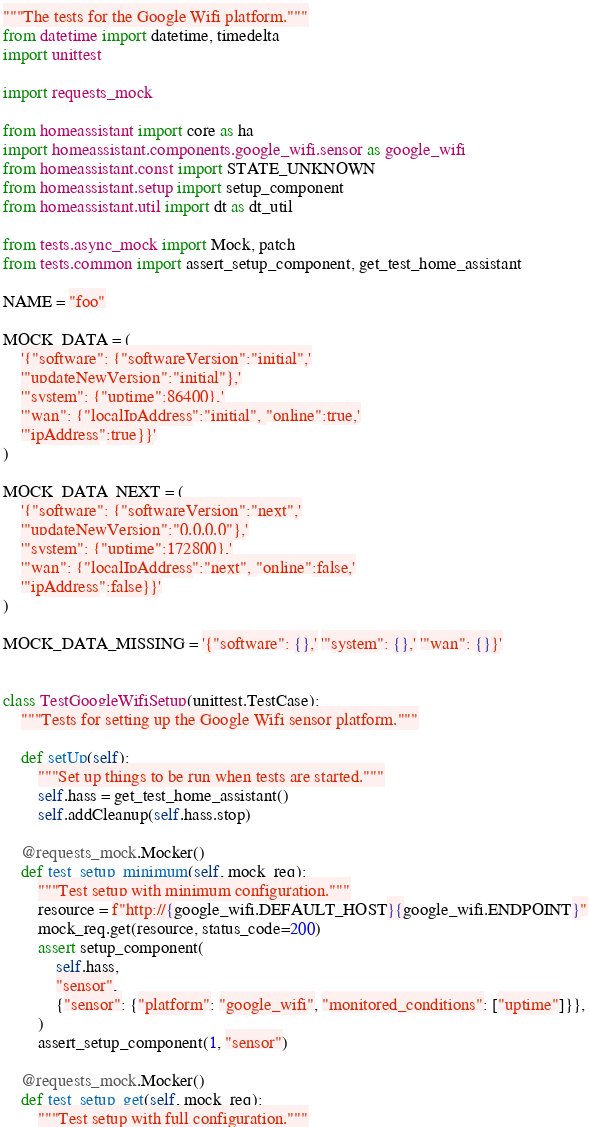Convert code to text. <code><loc_0><loc_0><loc_500><loc_500><_Python_>"""The tests for the Google Wifi platform."""
from datetime import datetime, timedelta
import unittest

import requests_mock

from homeassistant import core as ha
import homeassistant.components.google_wifi.sensor as google_wifi
from homeassistant.const import STATE_UNKNOWN
from homeassistant.setup import setup_component
from homeassistant.util import dt as dt_util

from tests.async_mock import Mock, patch
from tests.common import assert_setup_component, get_test_home_assistant

NAME = "foo"

MOCK_DATA = (
    '{"software": {"softwareVersion":"initial",'
    '"updateNewVersion":"initial"},'
    '"system": {"uptime":86400},'
    '"wan": {"localIpAddress":"initial", "online":true,'
    '"ipAddress":true}}'
)

MOCK_DATA_NEXT = (
    '{"software": {"softwareVersion":"next",'
    '"updateNewVersion":"0.0.0.0"},'
    '"system": {"uptime":172800},'
    '"wan": {"localIpAddress":"next", "online":false,'
    '"ipAddress":false}}'
)

MOCK_DATA_MISSING = '{"software": {},' '"system": {},' '"wan": {}}'


class TestGoogleWifiSetup(unittest.TestCase):
    """Tests for setting up the Google Wifi sensor platform."""

    def setUp(self):
        """Set up things to be run when tests are started."""
        self.hass = get_test_home_assistant()
        self.addCleanup(self.hass.stop)

    @requests_mock.Mocker()
    def test_setup_minimum(self, mock_req):
        """Test setup with minimum configuration."""
        resource = f"http://{google_wifi.DEFAULT_HOST}{google_wifi.ENDPOINT}"
        mock_req.get(resource, status_code=200)
        assert setup_component(
            self.hass,
            "sensor",
            {"sensor": {"platform": "google_wifi", "monitored_conditions": ["uptime"]}},
        )
        assert_setup_component(1, "sensor")

    @requests_mock.Mocker()
    def test_setup_get(self, mock_req):
        """Test setup with full configuration."""</code> 